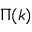Convert formula to latex. <formula><loc_0><loc_0><loc_500><loc_500>\Pi ( k )</formula> 